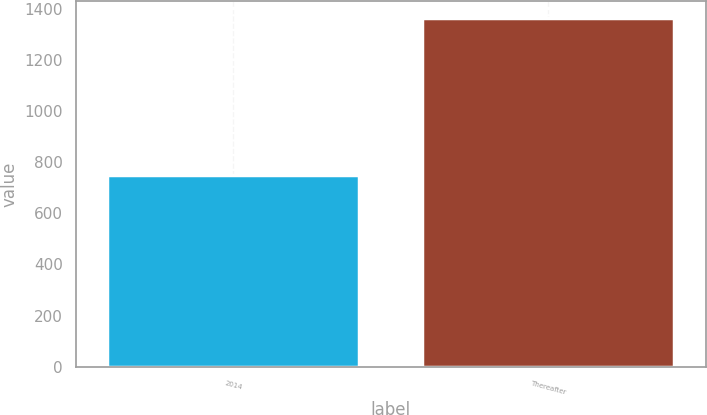Convert chart to OTSL. <chart><loc_0><loc_0><loc_500><loc_500><bar_chart><fcel>2014<fcel>Thereafter<nl><fcel>750<fcel>1362.5<nl></chart> 